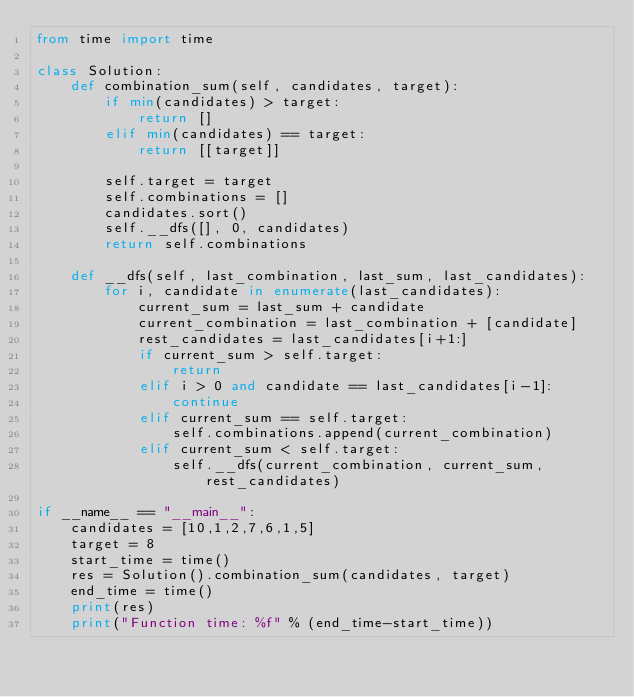<code> <loc_0><loc_0><loc_500><loc_500><_Python_>from time import time

class Solution:
    def combination_sum(self, candidates, target):
        if min(candidates) > target:
            return []
        elif min(candidates) == target:
            return [[target]]

        self.target = target
        self.combinations = []
        candidates.sort()
        self.__dfs([], 0, candidates)
        return self.combinations

    def __dfs(self, last_combination, last_sum, last_candidates):
        for i, candidate in enumerate(last_candidates):
            current_sum = last_sum + candidate
            current_combination = last_combination + [candidate]
            rest_candidates = last_candidates[i+1:]
            if current_sum > self.target:
                return
            elif i > 0 and candidate == last_candidates[i-1]:
                continue
            elif current_sum == self.target:
                self.combinations.append(current_combination)
            elif current_sum < self.target:
                self.__dfs(current_combination, current_sum, rest_candidates)

if __name__ == "__main__":
    candidates = [10,1,2,7,6,1,5]
    target = 8
    start_time = time()
    res = Solution().combination_sum(candidates, target)
    end_time = time()
    print(res)
    print("Function time: %f" % (end_time-start_time))</code> 